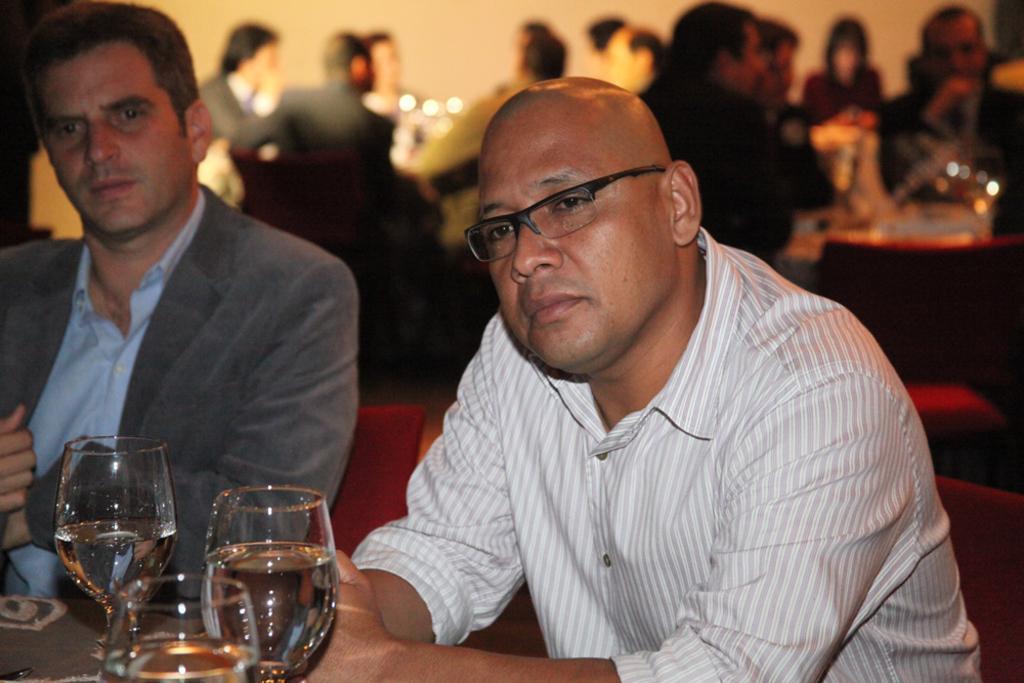In one or two sentences, can you explain what this image depicts? In this image we can see two persons sitting and in front of them there is a table with few glasses and in the background, we can see some people sitting and the image is blurred. 